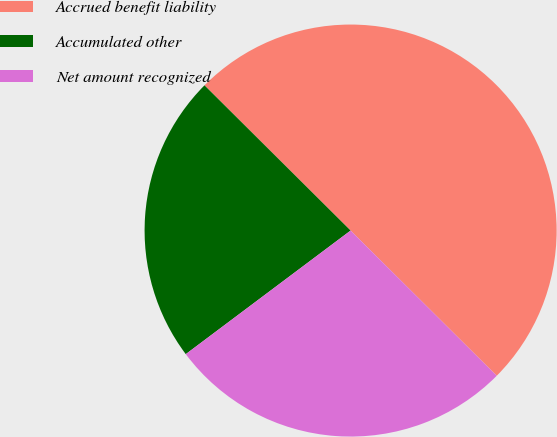Convert chart to OTSL. <chart><loc_0><loc_0><loc_500><loc_500><pie_chart><fcel>Accrued benefit liability<fcel>Accumulated other<fcel>Net amount recognized<nl><fcel>50.0%<fcel>22.69%<fcel>27.31%<nl></chart> 